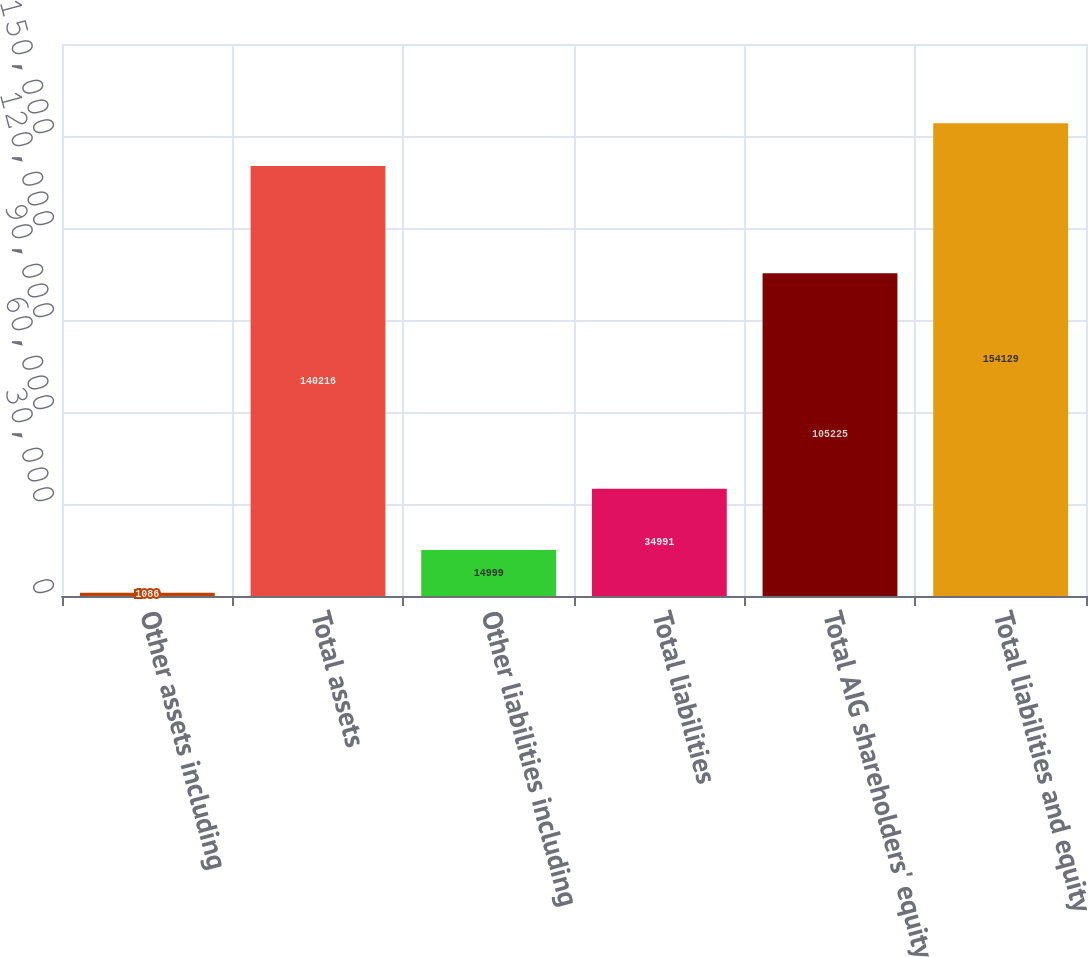Convert chart. <chart><loc_0><loc_0><loc_500><loc_500><bar_chart><fcel>Other assets including<fcel>Total assets<fcel>Other liabilities including<fcel>Total liabilities<fcel>Total AIG shareholders' equity<fcel>Total liabilities and equity<nl><fcel>1086<fcel>140216<fcel>14999<fcel>34991<fcel>105225<fcel>154129<nl></chart> 